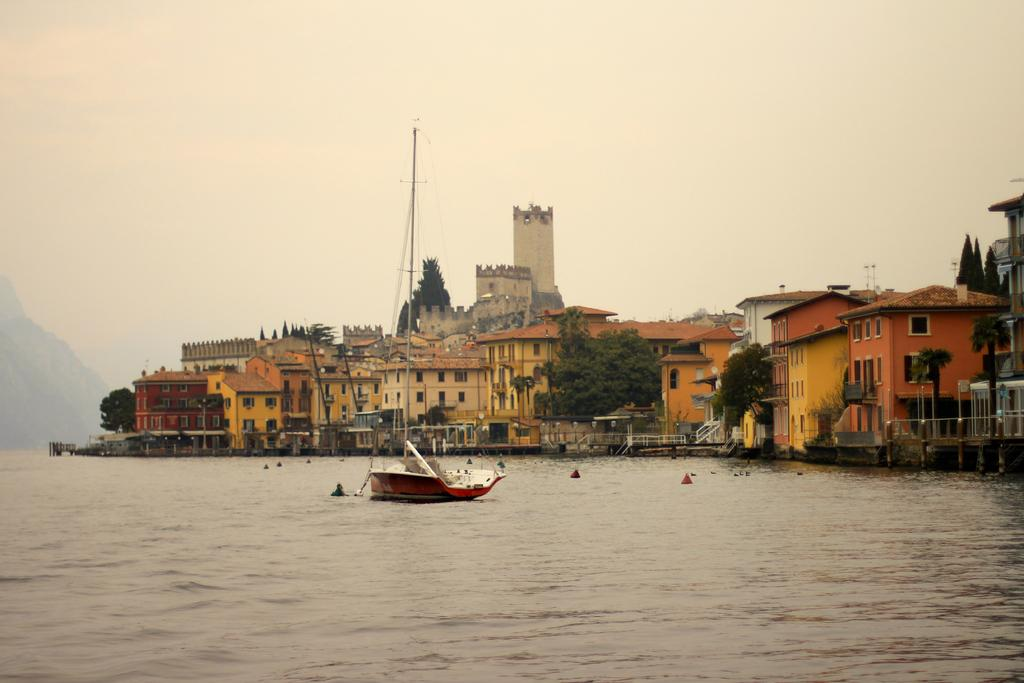What is the main subject of the image? The main subject of the image is a boat. What features does the boat have? The boat has a pole and ropes. Where is the boat located? The boat is on the water. What can be seen in the background of the image? There are trees, buildings with windows, and the sky visible in the background of the image. What type of truck can be seen carrying a box in the image? There is no truck or box present in the image; it features a boat on the water. How many births are depicted in the image? There are no births depicted in the image; it features a boat with a pole and ropes on the water. 